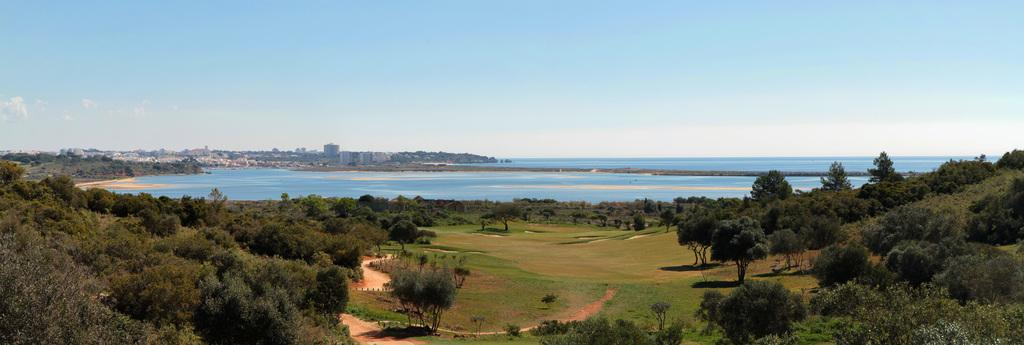What type of natural elements can be seen in the image? There are trees and a river in the image. What type of man-made structures are present in the image? There are buildings in the image. What part of the natural environment is visible in the image? The sky is visible in the image. Can you see a car driving through the river in the image? There is no car driving through the river in the image. What color are the lips of the person standing near the trees? There are no people or lips present in the image. 